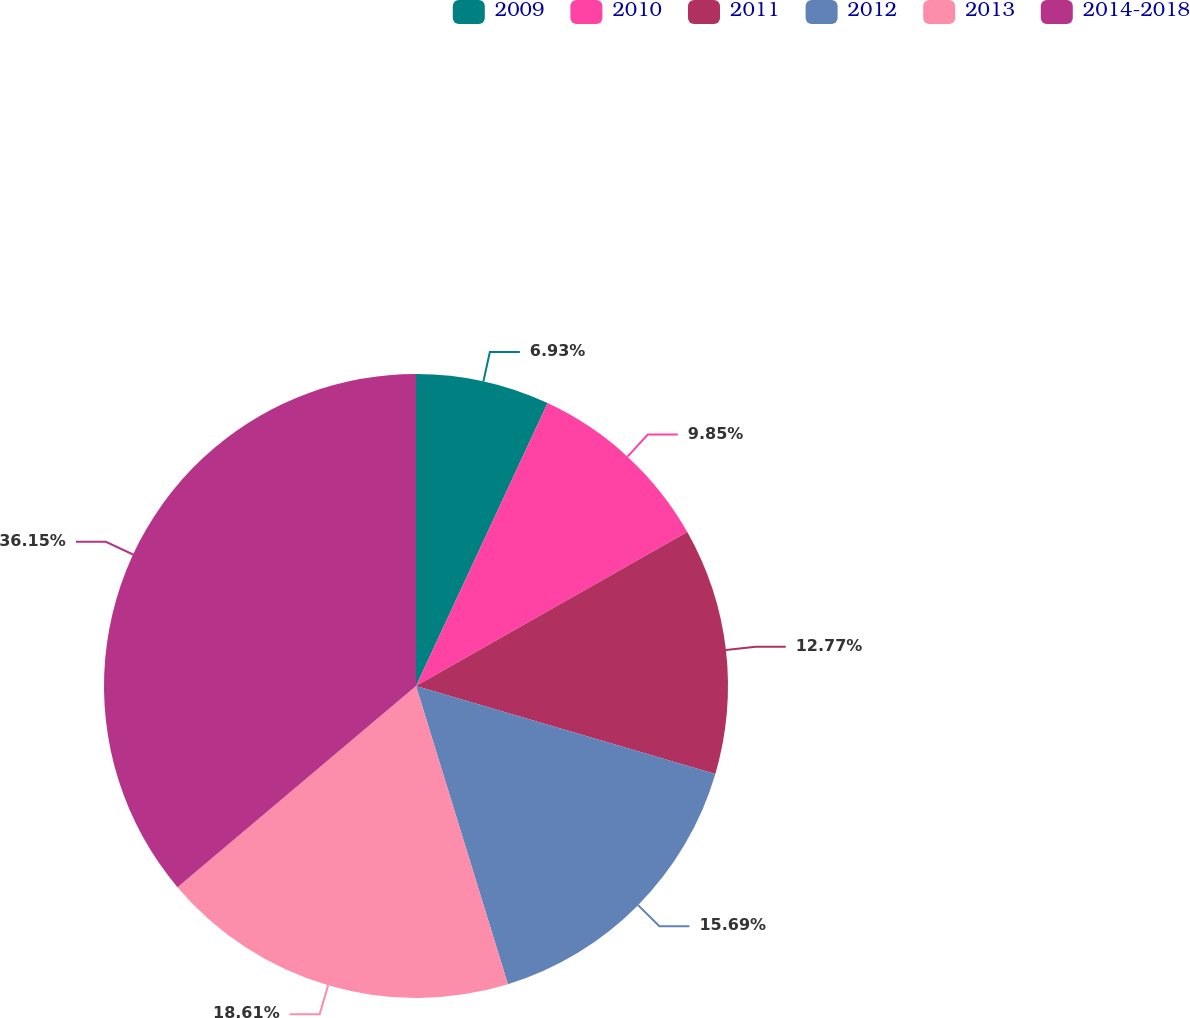Convert chart to OTSL. <chart><loc_0><loc_0><loc_500><loc_500><pie_chart><fcel>2009<fcel>2010<fcel>2011<fcel>2012<fcel>2013<fcel>2014-2018<nl><fcel>6.93%<fcel>9.85%<fcel>12.77%<fcel>15.69%<fcel>18.61%<fcel>36.15%<nl></chart> 